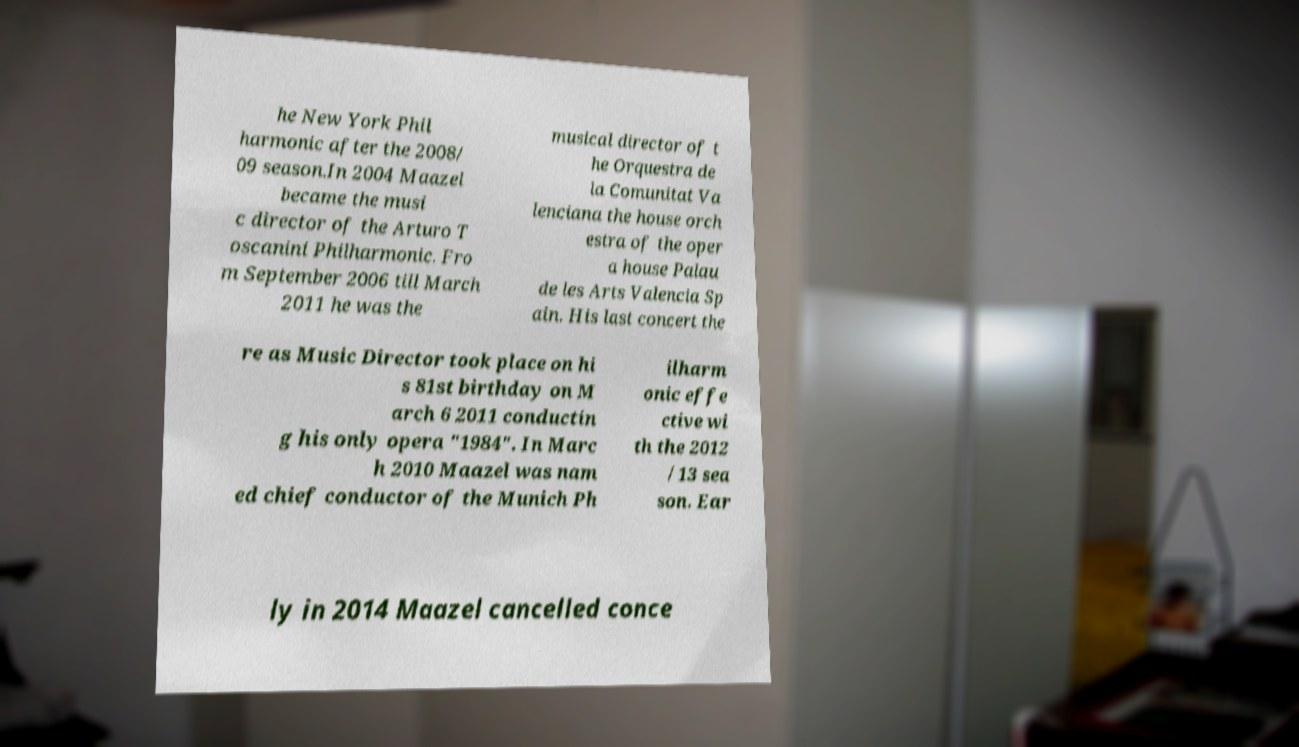Could you extract and type out the text from this image? he New York Phil harmonic after the 2008/ 09 season.In 2004 Maazel became the musi c director of the Arturo T oscanini Philharmonic. Fro m September 2006 till March 2011 he was the musical director of t he Orquestra de la Comunitat Va lenciana the house orch estra of the oper a house Palau de les Arts Valencia Sp ain. His last concert the re as Music Director took place on hi s 81st birthday on M arch 6 2011 conductin g his only opera "1984". In Marc h 2010 Maazel was nam ed chief conductor of the Munich Ph ilharm onic effe ctive wi th the 2012 /13 sea son. Ear ly in 2014 Maazel cancelled conce 